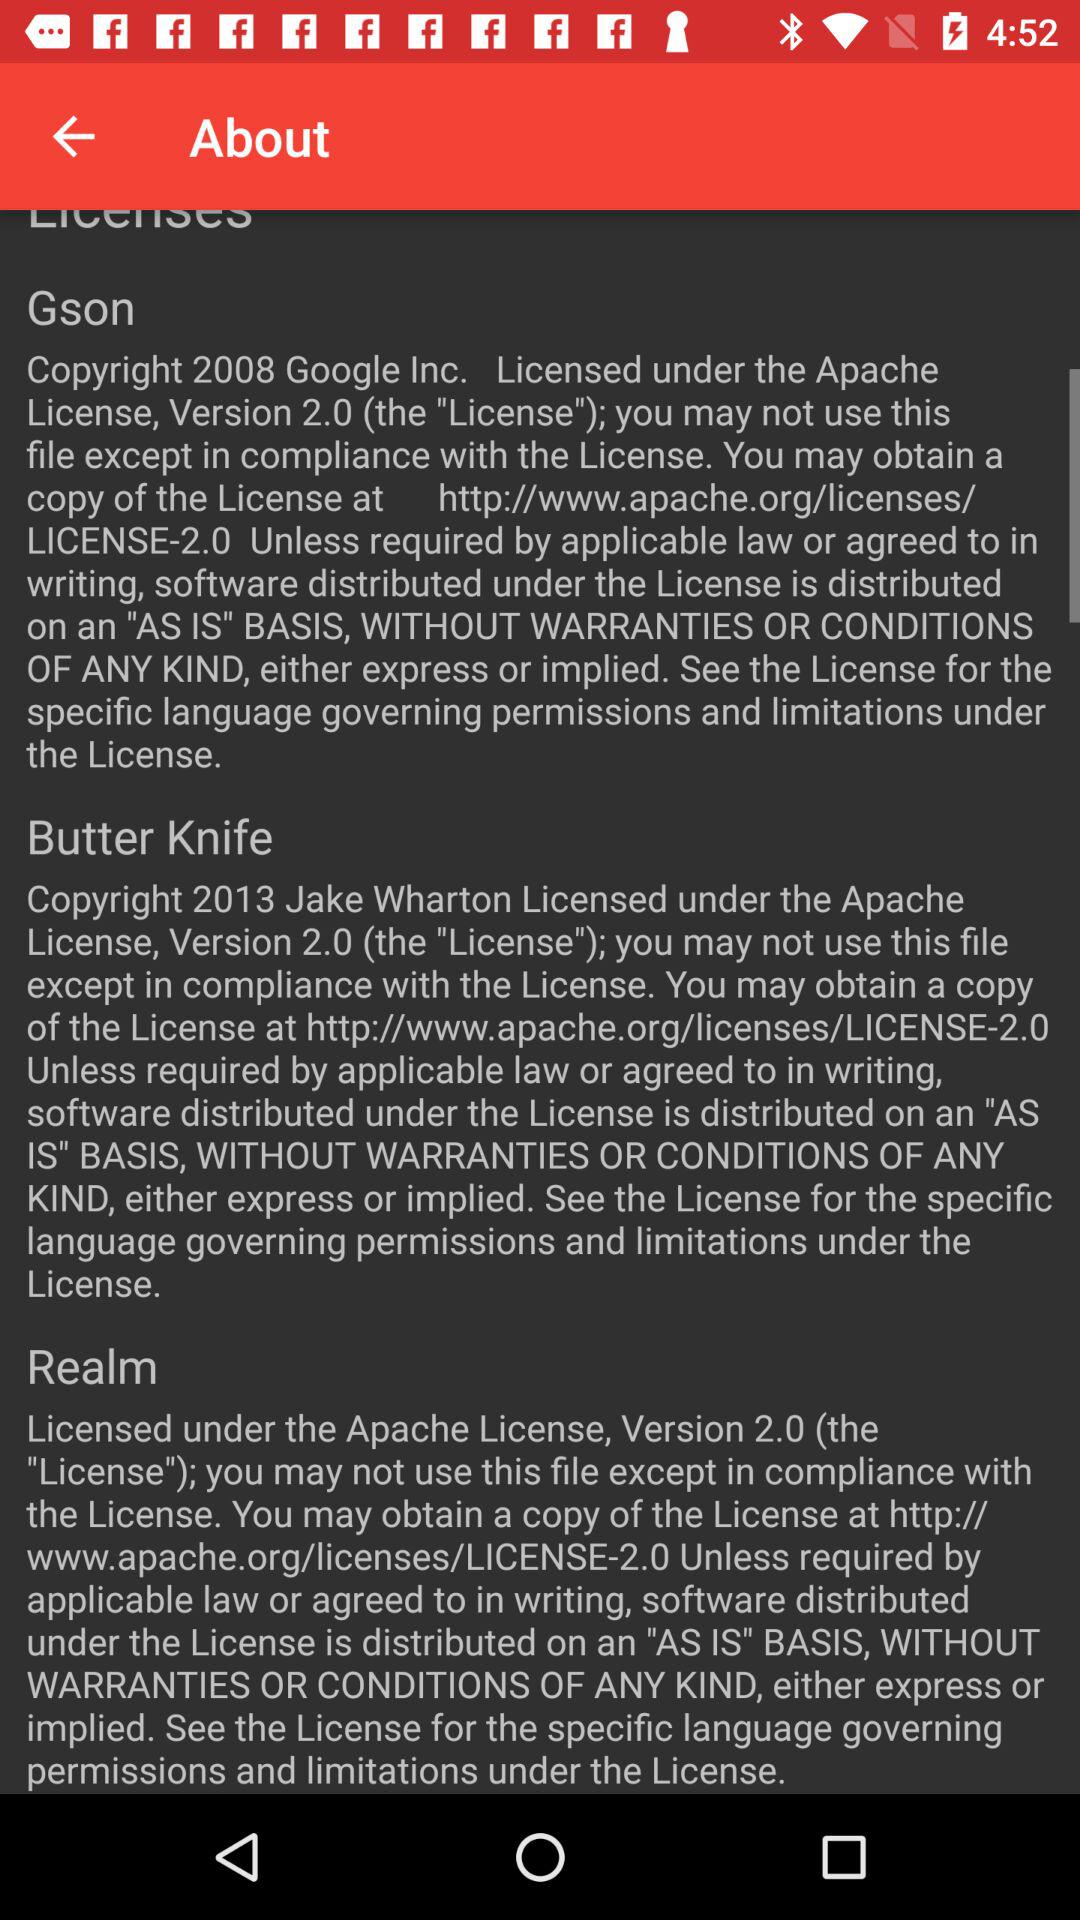How many licenses are there?
Answer the question using a single word or phrase. 3 